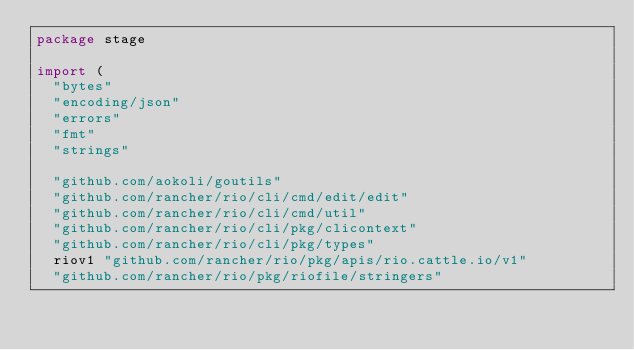<code> <loc_0><loc_0><loc_500><loc_500><_Go_>package stage

import (
	"bytes"
	"encoding/json"
	"errors"
	"fmt"
	"strings"

	"github.com/aokoli/goutils"
	"github.com/rancher/rio/cli/cmd/edit/edit"
	"github.com/rancher/rio/cli/cmd/util"
	"github.com/rancher/rio/cli/pkg/clicontext"
	"github.com/rancher/rio/cli/pkg/types"
	riov1 "github.com/rancher/rio/pkg/apis/rio.cattle.io/v1"
	"github.com/rancher/rio/pkg/riofile/stringers"</code> 